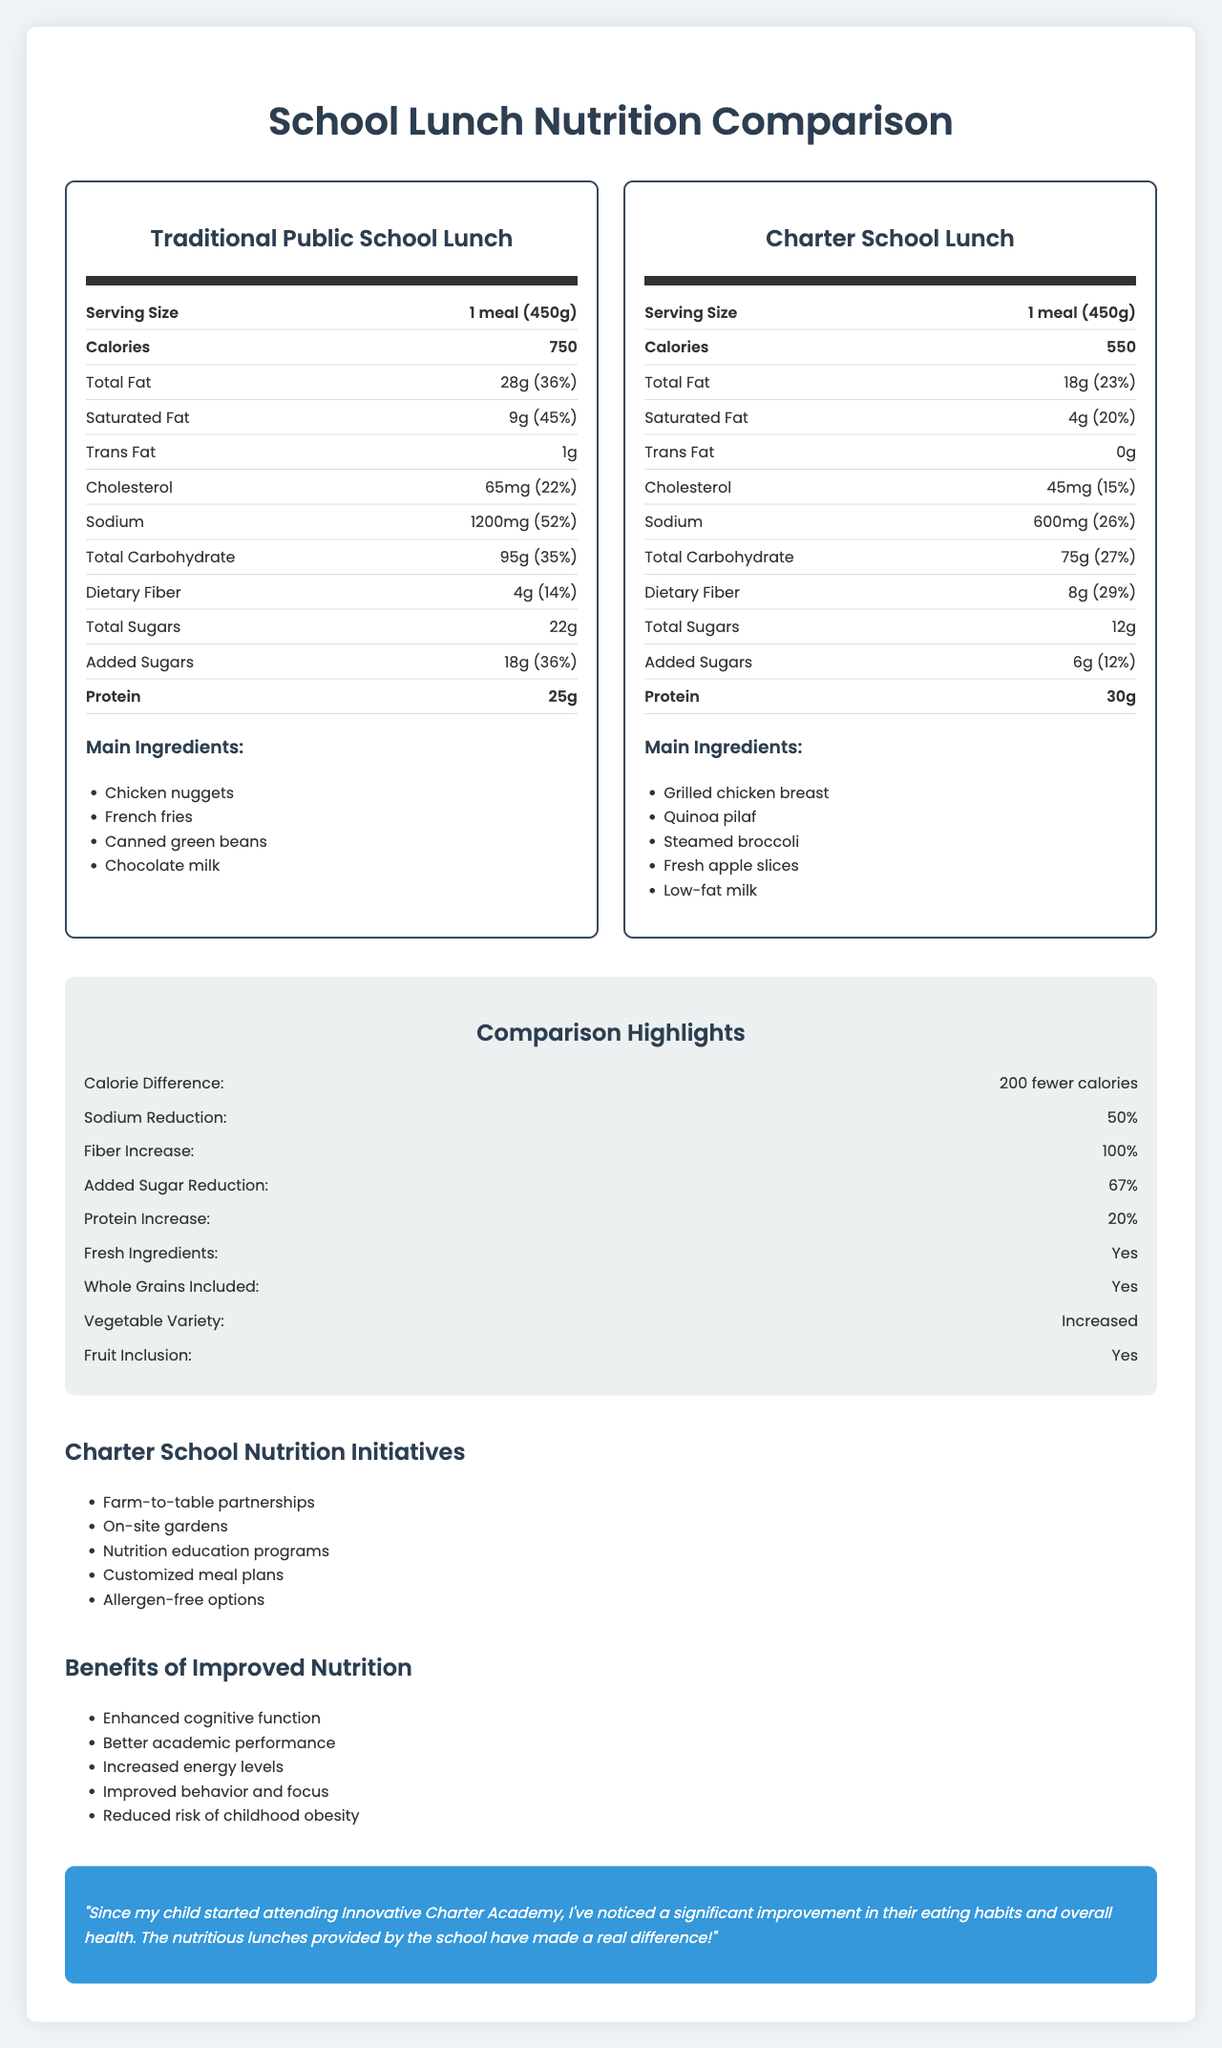Short-Answer:
1. What is the serving size for both traditional public school lunch and charter school lunch? The serving size for both lunches is the same: 1 meal (450g), as indicated on both nutrition labels.
Answer: 1 meal (450g) 2. How many calories are in the traditional public school lunch? The traditional public school lunch contains 750 calories, as noted in its nutrition label.
Answer: 750 3. What is the total fat content in the charter school lunch? The total fat content in the charter school lunch is 18 grams, which is listed in the nutrition facts.
Answer: 18g 4. How much dietary fiber does the charter school lunch have compared to the traditional public school lunch? The charter school lunch has 8 grams of dietary fiber, whereas the traditional public school lunch has 4 grams.
Answer: Charter school lunch: 8g, Traditional public school lunch: 4g 5. What are the main ingredients in the charter school lunch? The main ingredients listed for the charter school lunch include grilled chicken breast, quinoa pilaf, steamed broccoli, fresh apple slices, and low-fat milk.
Answer: Grilled chicken breast, Quinoa pilaf, Steamed broccoli, Fresh apple slices, Low-fat milk Multiple-Choice:
1. How much cholesterol is in the traditional public school lunch? 
   A. 45mg
   B. 65mg
   C. 50mg The traditional public school lunch contains 65mg of cholesterol, according to its nutrition facts.
Answer: B 2. What is the amount of added sugars in the charter school lunch?
   I. 12g
   II. 6g
   III. 18g
   IV. 22g The nutrition facts indicate that the charter school lunch contains 6g of added sugars.
Answer: II Yes/No:
1. Does the traditional public school lunch contain trans fat? The nutrition facts label for the traditional public school lunch lists 1g of trans fat.
Answer: Yes Summary:
1. Summarize the main idea of the document. The document outlines the nutritional information for both traditional public school and charter school lunches, showcasing the benefits of the charter school's healthier options. It emphasizes reduced calories, sodium, and sugars, increased fiber and protein, and the inclusion of fresh ingredients and whole grains in charter school lunches. Additionally, it highlights the associated benefits and initiatives designed to improve student nutrition.
Answer: The document provides a detailed comparison of the nutritional content of traditional public school and charter school lunches, highlighting key differences in calories, fat, sodium, carbohydrates, fiber, sugars, protein, and main ingredients. It includes comparisons of various nutritional initiatives and the benefits of improved nutrition, alongside a parent testimonial. Unanswerable:
1. What is the cost of a traditional public school lunch? The cost of the traditional public school lunch is not provided in the document's nutrition facts or any other sections.
Answer: Not enough information 